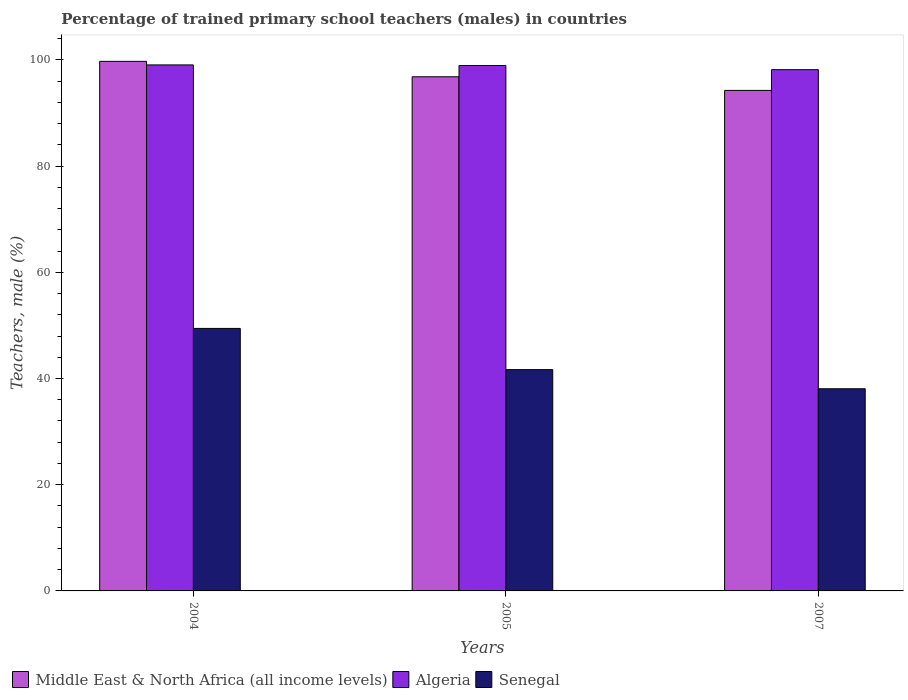How many different coloured bars are there?
Your answer should be compact. 3. Are the number of bars per tick equal to the number of legend labels?
Provide a short and direct response. Yes. How many bars are there on the 2nd tick from the right?
Your answer should be very brief. 3. What is the label of the 3rd group of bars from the left?
Offer a terse response. 2007. What is the percentage of trained primary school teachers (males) in Middle East & North Africa (all income levels) in 2004?
Offer a terse response. 99.73. Across all years, what is the maximum percentage of trained primary school teachers (males) in Algeria?
Provide a short and direct response. 99.06. Across all years, what is the minimum percentage of trained primary school teachers (males) in Senegal?
Give a very brief answer. 38.07. In which year was the percentage of trained primary school teachers (males) in Algeria maximum?
Offer a terse response. 2004. What is the total percentage of trained primary school teachers (males) in Senegal in the graph?
Your response must be concise. 129.18. What is the difference between the percentage of trained primary school teachers (males) in Senegal in 2004 and that in 2005?
Provide a succinct answer. 7.76. What is the difference between the percentage of trained primary school teachers (males) in Senegal in 2007 and the percentage of trained primary school teachers (males) in Middle East & North Africa (all income levels) in 2004?
Offer a very short reply. -61.66. What is the average percentage of trained primary school teachers (males) in Senegal per year?
Your response must be concise. 43.06. In the year 2004, what is the difference between the percentage of trained primary school teachers (males) in Middle East & North Africa (all income levels) and percentage of trained primary school teachers (males) in Algeria?
Provide a short and direct response. 0.67. What is the ratio of the percentage of trained primary school teachers (males) in Senegal in 2004 to that in 2005?
Give a very brief answer. 1.19. Is the difference between the percentage of trained primary school teachers (males) in Middle East & North Africa (all income levels) in 2005 and 2007 greater than the difference between the percentage of trained primary school teachers (males) in Algeria in 2005 and 2007?
Make the answer very short. Yes. What is the difference between the highest and the second highest percentage of trained primary school teachers (males) in Middle East & North Africa (all income levels)?
Your answer should be compact. 2.9. What is the difference between the highest and the lowest percentage of trained primary school teachers (males) in Senegal?
Offer a very short reply. 11.37. In how many years, is the percentage of trained primary school teachers (males) in Middle East & North Africa (all income levels) greater than the average percentage of trained primary school teachers (males) in Middle East & North Africa (all income levels) taken over all years?
Make the answer very short. 1. Is the sum of the percentage of trained primary school teachers (males) in Senegal in 2004 and 2007 greater than the maximum percentage of trained primary school teachers (males) in Algeria across all years?
Your response must be concise. No. What does the 3rd bar from the left in 2007 represents?
Give a very brief answer. Senegal. What does the 2nd bar from the right in 2004 represents?
Keep it short and to the point. Algeria. Is it the case that in every year, the sum of the percentage of trained primary school teachers (males) in Senegal and percentage of trained primary school teachers (males) in Algeria is greater than the percentage of trained primary school teachers (males) in Middle East & North Africa (all income levels)?
Your response must be concise. Yes. How many bars are there?
Make the answer very short. 9. Are the values on the major ticks of Y-axis written in scientific E-notation?
Your answer should be very brief. No. Where does the legend appear in the graph?
Give a very brief answer. Bottom left. How many legend labels are there?
Your response must be concise. 3. How are the legend labels stacked?
Give a very brief answer. Horizontal. What is the title of the graph?
Offer a terse response. Percentage of trained primary school teachers (males) in countries. What is the label or title of the X-axis?
Offer a terse response. Years. What is the label or title of the Y-axis?
Provide a succinct answer. Teachers, male (%). What is the Teachers, male (%) in Middle East & North Africa (all income levels) in 2004?
Provide a short and direct response. 99.73. What is the Teachers, male (%) of Algeria in 2004?
Provide a succinct answer. 99.06. What is the Teachers, male (%) of Senegal in 2004?
Your answer should be compact. 49.44. What is the Teachers, male (%) in Middle East & North Africa (all income levels) in 2005?
Ensure brevity in your answer.  96.83. What is the Teachers, male (%) in Algeria in 2005?
Provide a succinct answer. 98.95. What is the Teachers, male (%) in Senegal in 2005?
Your answer should be very brief. 41.68. What is the Teachers, male (%) of Middle East & North Africa (all income levels) in 2007?
Ensure brevity in your answer.  94.26. What is the Teachers, male (%) of Algeria in 2007?
Provide a short and direct response. 98.16. What is the Teachers, male (%) in Senegal in 2007?
Your answer should be very brief. 38.07. Across all years, what is the maximum Teachers, male (%) of Middle East & North Africa (all income levels)?
Provide a short and direct response. 99.73. Across all years, what is the maximum Teachers, male (%) in Algeria?
Ensure brevity in your answer.  99.06. Across all years, what is the maximum Teachers, male (%) of Senegal?
Your answer should be very brief. 49.44. Across all years, what is the minimum Teachers, male (%) of Middle East & North Africa (all income levels)?
Provide a succinct answer. 94.26. Across all years, what is the minimum Teachers, male (%) of Algeria?
Your answer should be very brief. 98.16. Across all years, what is the minimum Teachers, male (%) of Senegal?
Ensure brevity in your answer.  38.07. What is the total Teachers, male (%) of Middle East & North Africa (all income levels) in the graph?
Offer a terse response. 290.81. What is the total Teachers, male (%) in Algeria in the graph?
Your answer should be very brief. 296.17. What is the total Teachers, male (%) in Senegal in the graph?
Ensure brevity in your answer.  129.18. What is the difference between the Teachers, male (%) in Middle East & North Africa (all income levels) in 2004 and that in 2005?
Your answer should be very brief. 2.9. What is the difference between the Teachers, male (%) in Algeria in 2004 and that in 2005?
Your response must be concise. 0.11. What is the difference between the Teachers, male (%) in Senegal in 2004 and that in 2005?
Offer a terse response. 7.76. What is the difference between the Teachers, male (%) of Middle East & North Africa (all income levels) in 2004 and that in 2007?
Keep it short and to the point. 5.47. What is the difference between the Teachers, male (%) in Algeria in 2004 and that in 2007?
Give a very brief answer. 0.9. What is the difference between the Teachers, male (%) of Senegal in 2004 and that in 2007?
Offer a terse response. 11.37. What is the difference between the Teachers, male (%) in Middle East & North Africa (all income levels) in 2005 and that in 2007?
Your answer should be very brief. 2.57. What is the difference between the Teachers, male (%) in Algeria in 2005 and that in 2007?
Ensure brevity in your answer.  0.79. What is the difference between the Teachers, male (%) in Senegal in 2005 and that in 2007?
Your answer should be compact. 3.6. What is the difference between the Teachers, male (%) in Middle East & North Africa (all income levels) in 2004 and the Teachers, male (%) in Algeria in 2005?
Keep it short and to the point. 0.78. What is the difference between the Teachers, male (%) in Middle East & North Africa (all income levels) in 2004 and the Teachers, male (%) in Senegal in 2005?
Your answer should be compact. 58.05. What is the difference between the Teachers, male (%) in Algeria in 2004 and the Teachers, male (%) in Senegal in 2005?
Make the answer very short. 57.38. What is the difference between the Teachers, male (%) of Middle East & North Africa (all income levels) in 2004 and the Teachers, male (%) of Algeria in 2007?
Ensure brevity in your answer.  1.57. What is the difference between the Teachers, male (%) in Middle East & North Africa (all income levels) in 2004 and the Teachers, male (%) in Senegal in 2007?
Offer a very short reply. 61.66. What is the difference between the Teachers, male (%) of Algeria in 2004 and the Teachers, male (%) of Senegal in 2007?
Provide a succinct answer. 60.99. What is the difference between the Teachers, male (%) of Middle East & North Africa (all income levels) in 2005 and the Teachers, male (%) of Algeria in 2007?
Your answer should be very brief. -1.34. What is the difference between the Teachers, male (%) in Middle East & North Africa (all income levels) in 2005 and the Teachers, male (%) in Senegal in 2007?
Offer a very short reply. 58.75. What is the difference between the Teachers, male (%) in Algeria in 2005 and the Teachers, male (%) in Senegal in 2007?
Your response must be concise. 60.88. What is the average Teachers, male (%) of Middle East & North Africa (all income levels) per year?
Keep it short and to the point. 96.94. What is the average Teachers, male (%) in Algeria per year?
Make the answer very short. 98.72. What is the average Teachers, male (%) in Senegal per year?
Make the answer very short. 43.06. In the year 2004, what is the difference between the Teachers, male (%) in Middle East & North Africa (all income levels) and Teachers, male (%) in Algeria?
Your response must be concise. 0.67. In the year 2004, what is the difference between the Teachers, male (%) of Middle East & North Africa (all income levels) and Teachers, male (%) of Senegal?
Offer a very short reply. 50.29. In the year 2004, what is the difference between the Teachers, male (%) in Algeria and Teachers, male (%) in Senegal?
Make the answer very short. 49.62. In the year 2005, what is the difference between the Teachers, male (%) of Middle East & North Africa (all income levels) and Teachers, male (%) of Algeria?
Your answer should be compact. -2.12. In the year 2005, what is the difference between the Teachers, male (%) in Middle East & North Africa (all income levels) and Teachers, male (%) in Senegal?
Offer a very short reply. 55.15. In the year 2005, what is the difference between the Teachers, male (%) of Algeria and Teachers, male (%) of Senegal?
Your answer should be compact. 57.27. In the year 2007, what is the difference between the Teachers, male (%) in Middle East & North Africa (all income levels) and Teachers, male (%) in Algeria?
Ensure brevity in your answer.  -3.9. In the year 2007, what is the difference between the Teachers, male (%) of Middle East & North Africa (all income levels) and Teachers, male (%) of Senegal?
Your answer should be compact. 56.19. In the year 2007, what is the difference between the Teachers, male (%) in Algeria and Teachers, male (%) in Senegal?
Your answer should be compact. 60.09. What is the ratio of the Teachers, male (%) in Middle East & North Africa (all income levels) in 2004 to that in 2005?
Provide a succinct answer. 1.03. What is the ratio of the Teachers, male (%) of Algeria in 2004 to that in 2005?
Provide a short and direct response. 1. What is the ratio of the Teachers, male (%) of Senegal in 2004 to that in 2005?
Ensure brevity in your answer.  1.19. What is the ratio of the Teachers, male (%) of Middle East & North Africa (all income levels) in 2004 to that in 2007?
Provide a short and direct response. 1.06. What is the ratio of the Teachers, male (%) of Algeria in 2004 to that in 2007?
Keep it short and to the point. 1.01. What is the ratio of the Teachers, male (%) of Senegal in 2004 to that in 2007?
Make the answer very short. 1.3. What is the ratio of the Teachers, male (%) in Middle East & North Africa (all income levels) in 2005 to that in 2007?
Offer a very short reply. 1.03. What is the ratio of the Teachers, male (%) of Senegal in 2005 to that in 2007?
Offer a very short reply. 1.09. What is the difference between the highest and the second highest Teachers, male (%) in Middle East & North Africa (all income levels)?
Ensure brevity in your answer.  2.9. What is the difference between the highest and the second highest Teachers, male (%) in Algeria?
Keep it short and to the point. 0.11. What is the difference between the highest and the second highest Teachers, male (%) in Senegal?
Offer a very short reply. 7.76. What is the difference between the highest and the lowest Teachers, male (%) of Middle East & North Africa (all income levels)?
Ensure brevity in your answer.  5.47. What is the difference between the highest and the lowest Teachers, male (%) in Algeria?
Offer a very short reply. 0.9. What is the difference between the highest and the lowest Teachers, male (%) in Senegal?
Give a very brief answer. 11.37. 